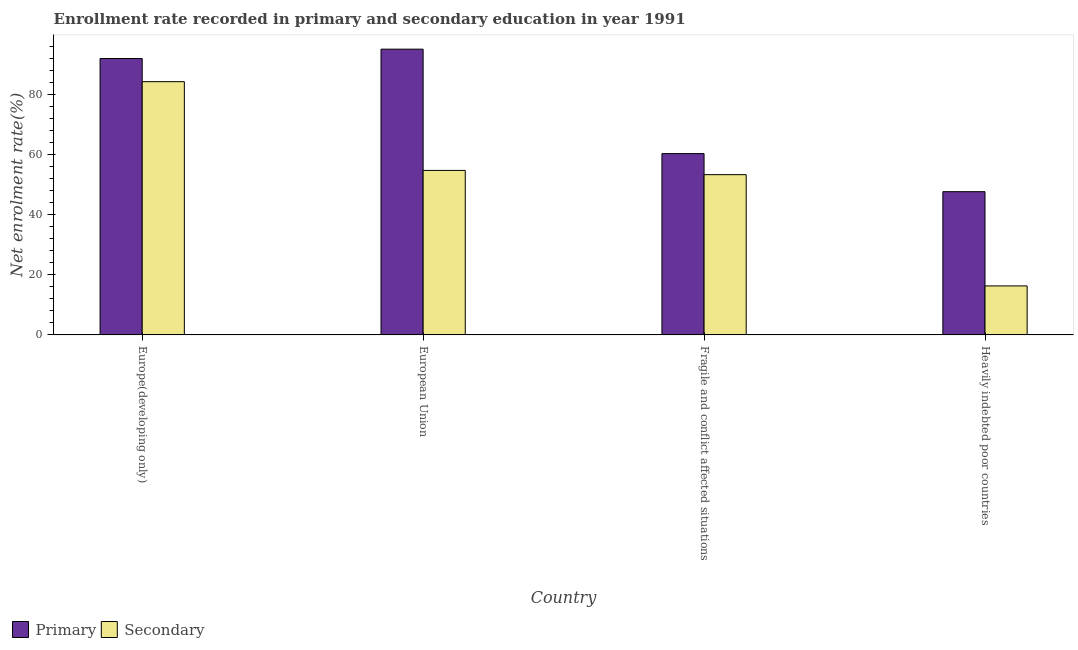Are the number of bars per tick equal to the number of legend labels?
Offer a very short reply. Yes. How many bars are there on the 2nd tick from the left?
Your response must be concise. 2. What is the label of the 3rd group of bars from the left?
Offer a very short reply. Fragile and conflict affected situations. In how many cases, is the number of bars for a given country not equal to the number of legend labels?
Give a very brief answer. 0. What is the enrollment rate in primary education in Heavily indebted poor countries?
Provide a short and direct response. 47.63. Across all countries, what is the maximum enrollment rate in secondary education?
Provide a succinct answer. 84.21. Across all countries, what is the minimum enrollment rate in primary education?
Your answer should be very brief. 47.63. In which country was the enrollment rate in primary education maximum?
Give a very brief answer. European Union. In which country was the enrollment rate in primary education minimum?
Provide a succinct answer. Heavily indebted poor countries. What is the total enrollment rate in secondary education in the graph?
Keep it short and to the point. 208.5. What is the difference between the enrollment rate in primary education in European Union and that in Heavily indebted poor countries?
Your answer should be compact. 47.39. What is the difference between the enrollment rate in primary education in Heavily indebted poor countries and the enrollment rate in secondary education in Europe(developing only)?
Keep it short and to the point. -36.58. What is the average enrollment rate in secondary education per country?
Offer a very short reply. 52.12. What is the difference between the enrollment rate in secondary education and enrollment rate in primary education in European Union?
Offer a terse response. -40.32. What is the ratio of the enrollment rate in primary education in European Union to that in Heavily indebted poor countries?
Keep it short and to the point. 1.99. Is the enrollment rate in secondary education in European Union less than that in Heavily indebted poor countries?
Your answer should be very brief. No. What is the difference between the highest and the second highest enrollment rate in secondary education?
Offer a very short reply. 29.52. What is the difference between the highest and the lowest enrollment rate in secondary education?
Make the answer very short. 67.92. What does the 1st bar from the left in Europe(developing only) represents?
Make the answer very short. Primary. What does the 2nd bar from the right in European Union represents?
Offer a very short reply. Primary. How many bars are there?
Your answer should be compact. 8. How many countries are there in the graph?
Your response must be concise. 4. Are the values on the major ticks of Y-axis written in scientific E-notation?
Provide a short and direct response. No. Does the graph contain grids?
Provide a short and direct response. No. How many legend labels are there?
Provide a succinct answer. 2. What is the title of the graph?
Your response must be concise. Enrollment rate recorded in primary and secondary education in year 1991. Does "GDP per capita" appear as one of the legend labels in the graph?
Ensure brevity in your answer.  No. What is the label or title of the X-axis?
Keep it short and to the point. Country. What is the label or title of the Y-axis?
Your answer should be compact. Net enrolment rate(%). What is the Net enrolment rate(%) of Primary in Europe(developing only)?
Your response must be concise. 91.91. What is the Net enrolment rate(%) of Secondary in Europe(developing only)?
Provide a succinct answer. 84.21. What is the Net enrolment rate(%) of Primary in European Union?
Your response must be concise. 95.02. What is the Net enrolment rate(%) of Secondary in European Union?
Ensure brevity in your answer.  54.7. What is the Net enrolment rate(%) of Primary in Fragile and conflict affected situations?
Give a very brief answer. 60.29. What is the Net enrolment rate(%) in Secondary in Fragile and conflict affected situations?
Give a very brief answer. 53.29. What is the Net enrolment rate(%) of Primary in Heavily indebted poor countries?
Make the answer very short. 47.63. What is the Net enrolment rate(%) of Secondary in Heavily indebted poor countries?
Provide a short and direct response. 16.3. Across all countries, what is the maximum Net enrolment rate(%) in Primary?
Provide a succinct answer. 95.02. Across all countries, what is the maximum Net enrolment rate(%) of Secondary?
Ensure brevity in your answer.  84.21. Across all countries, what is the minimum Net enrolment rate(%) in Primary?
Ensure brevity in your answer.  47.63. Across all countries, what is the minimum Net enrolment rate(%) of Secondary?
Provide a succinct answer. 16.3. What is the total Net enrolment rate(%) of Primary in the graph?
Give a very brief answer. 294.86. What is the total Net enrolment rate(%) of Secondary in the graph?
Your response must be concise. 208.5. What is the difference between the Net enrolment rate(%) of Primary in Europe(developing only) and that in European Union?
Provide a short and direct response. -3.11. What is the difference between the Net enrolment rate(%) of Secondary in Europe(developing only) and that in European Union?
Give a very brief answer. 29.52. What is the difference between the Net enrolment rate(%) in Primary in Europe(developing only) and that in Fragile and conflict affected situations?
Provide a short and direct response. 31.62. What is the difference between the Net enrolment rate(%) in Secondary in Europe(developing only) and that in Fragile and conflict affected situations?
Make the answer very short. 30.93. What is the difference between the Net enrolment rate(%) of Primary in Europe(developing only) and that in Heavily indebted poor countries?
Your answer should be compact. 44.28. What is the difference between the Net enrolment rate(%) of Secondary in Europe(developing only) and that in Heavily indebted poor countries?
Your answer should be compact. 67.92. What is the difference between the Net enrolment rate(%) in Primary in European Union and that in Fragile and conflict affected situations?
Give a very brief answer. 34.73. What is the difference between the Net enrolment rate(%) in Secondary in European Union and that in Fragile and conflict affected situations?
Give a very brief answer. 1.41. What is the difference between the Net enrolment rate(%) in Primary in European Union and that in Heavily indebted poor countries?
Keep it short and to the point. 47.39. What is the difference between the Net enrolment rate(%) in Secondary in European Union and that in Heavily indebted poor countries?
Ensure brevity in your answer.  38.4. What is the difference between the Net enrolment rate(%) of Primary in Fragile and conflict affected situations and that in Heavily indebted poor countries?
Provide a succinct answer. 12.66. What is the difference between the Net enrolment rate(%) in Secondary in Fragile and conflict affected situations and that in Heavily indebted poor countries?
Keep it short and to the point. 36.99. What is the difference between the Net enrolment rate(%) in Primary in Europe(developing only) and the Net enrolment rate(%) in Secondary in European Union?
Your answer should be compact. 37.21. What is the difference between the Net enrolment rate(%) of Primary in Europe(developing only) and the Net enrolment rate(%) of Secondary in Fragile and conflict affected situations?
Give a very brief answer. 38.63. What is the difference between the Net enrolment rate(%) in Primary in Europe(developing only) and the Net enrolment rate(%) in Secondary in Heavily indebted poor countries?
Your answer should be very brief. 75.62. What is the difference between the Net enrolment rate(%) of Primary in European Union and the Net enrolment rate(%) of Secondary in Fragile and conflict affected situations?
Provide a succinct answer. 41.73. What is the difference between the Net enrolment rate(%) in Primary in European Union and the Net enrolment rate(%) in Secondary in Heavily indebted poor countries?
Provide a succinct answer. 78.73. What is the difference between the Net enrolment rate(%) in Primary in Fragile and conflict affected situations and the Net enrolment rate(%) in Secondary in Heavily indebted poor countries?
Make the answer very short. 44. What is the average Net enrolment rate(%) in Primary per country?
Your answer should be compact. 73.71. What is the average Net enrolment rate(%) of Secondary per country?
Give a very brief answer. 52.12. What is the difference between the Net enrolment rate(%) of Primary and Net enrolment rate(%) of Secondary in Europe(developing only)?
Your response must be concise. 7.7. What is the difference between the Net enrolment rate(%) of Primary and Net enrolment rate(%) of Secondary in European Union?
Provide a short and direct response. 40.32. What is the difference between the Net enrolment rate(%) of Primary and Net enrolment rate(%) of Secondary in Fragile and conflict affected situations?
Make the answer very short. 7. What is the difference between the Net enrolment rate(%) in Primary and Net enrolment rate(%) in Secondary in Heavily indebted poor countries?
Offer a terse response. 31.34. What is the ratio of the Net enrolment rate(%) in Primary in Europe(developing only) to that in European Union?
Keep it short and to the point. 0.97. What is the ratio of the Net enrolment rate(%) of Secondary in Europe(developing only) to that in European Union?
Your response must be concise. 1.54. What is the ratio of the Net enrolment rate(%) in Primary in Europe(developing only) to that in Fragile and conflict affected situations?
Keep it short and to the point. 1.52. What is the ratio of the Net enrolment rate(%) of Secondary in Europe(developing only) to that in Fragile and conflict affected situations?
Ensure brevity in your answer.  1.58. What is the ratio of the Net enrolment rate(%) in Primary in Europe(developing only) to that in Heavily indebted poor countries?
Provide a short and direct response. 1.93. What is the ratio of the Net enrolment rate(%) in Secondary in Europe(developing only) to that in Heavily indebted poor countries?
Offer a terse response. 5.17. What is the ratio of the Net enrolment rate(%) in Primary in European Union to that in Fragile and conflict affected situations?
Offer a very short reply. 1.58. What is the ratio of the Net enrolment rate(%) in Secondary in European Union to that in Fragile and conflict affected situations?
Your answer should be very brief. 1.03. What is the ratio of the Net enrolment rate(%) of Primary in European Union to that in Heavily indebted poor countries?
Offer a terse response. 1.99. What is the ratio of the Net enrolment rate(%) of Secondary in European Union to that in Heavily indebted poor countries?
Provide a short and direct response. 3.36. What is the ratio of the Net enrolment rate(%) in Primary in Fragile and conflict affected situations to that in Heavily indebted poor countries?
Give a very brief answer. 1.27. What is the ratio of the Net enrolment rate(%) in Secondary in Fragile and conflict affected situations to that in Heavily indebted poor countries?
Ensure brevity in your answer.  3.27. What is the difference between the highest and the second highest Net enrolment rate(%) in Primary?
Provide a succinct answer. 3.11. What is the difference between the highest and the second highest Net enrolment rate(%) of Secondary?
Your response must be concise. 29.52. What is the difference between the highest and the lowest Net enrolment rate(%) in Primary?
Give a very brief answer. 47.39. What is the difference between the highest and the lowest Net enrolment rate(%) in Secondary?
Make the answer very short. 67.92. 